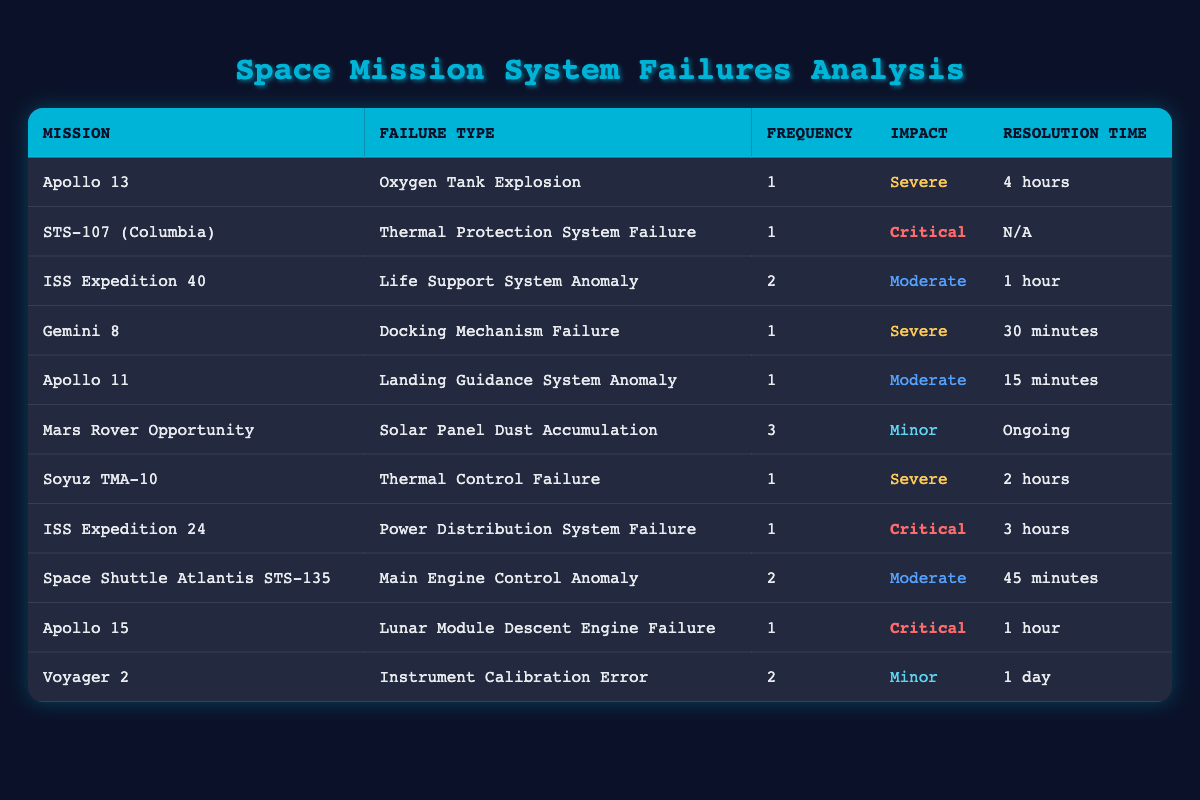What is the total frequency of system failures listed in the table? To find the total frequency of system failures, we need to add up the frequency values from all rows of the table: 1 + 1 + 2 + 1 + 1 + 3 + 1 + 1 + 2 + 1 + 2 = 16.
Answer: 16 Which mission experienced the longest resolution time among the listed failures? By examining the resolution time for each mission, the longest time is 4 hours for the Apollo 13 mission.
Answer: Apollo 13 How many system failures had a "Moderate" impact? There are three entries with a "Moderate" impact—ISS Expedition 40, Apollo 11, and Space Shuttle Atlantis STS-135.
Answer: 3 Is there any mission that had a "Critical" impact and a resolution time listed as "N/A"? Yes, the STS-107 (Columbia) mission experienced a Thermal Protection System Failure with a "Critical" impact, and its resolution time is listed as "N/A".
Answer: Yes What is the average frequency of the system failures across all missions? The total frequency is 16, and there are 11 missions. Therefore, the average frequency is 16/11, which is approximately 1.45 (rounded to two decimal places).
Answer: 1.45 Which failure type had the highest reported frequency? The failure type with the highest frequency is "Solar Panel Dust Accumulation" from Mars Rover Opportunity, which occurred 3 times.
Answer: Solar Panel Dust Accumulation Was there any mission with a "Severe" impact that resolved within 30 minutes? Yes, the Gemini 8 mission had a "Severe" impact with a Docking Mechanism Failure and a resolution time of 30 minutes.
Answer: Yes What is the sum of the frequencies for all missions with a "Critical" impact? The missions with a "Critical" impact are STS-107 (Columbia), ISS Expedition 24, and Apollo 15, each with a frequency of 1, 1, and 1 respectively. The sum is 1 + 1 + 1 = 3.
Answer: 3 How many missions had a resolution time of 1 hour or less? The missions with a resolution time of 1 hour or less are Apollo 11, Gemini 8, and Apollo 15. In total, there are 3 missions with this criterion.
Answer: 3 Was the "Oxygen Tank Explosion" the only failure type recorded for Apollo 13? Yes, Apollo 13 only records one failure type, which is the "Oxygen Tank Explosion".
Answer: Yes 